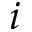Convert formula to latex. <formula><loc_0><loc_0><loc_500><loc_500>i</formula> 